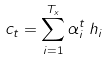<formula> <loc_0><loc_0><loc_500><loc_500>c _ { t } = \sum _ { i = 1 } ^ { T _ { x } } \alpha _ { i } ^ { t } \, h _ { i }</formula> 